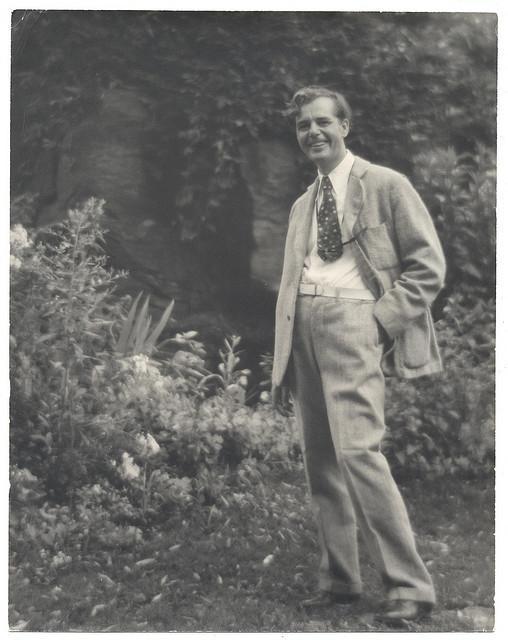How many images of the man are black and white?
Give a very brief answer. 1. 